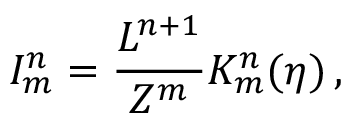<formula> <loc_0><loc_0><loc_500><loc_500>I _ { m } ^ { n } = \frac { L ^ { n + 1 } } { Z ^ { m } } K _ { m } ^ { n } ( \eta ) \, ,</formula> 